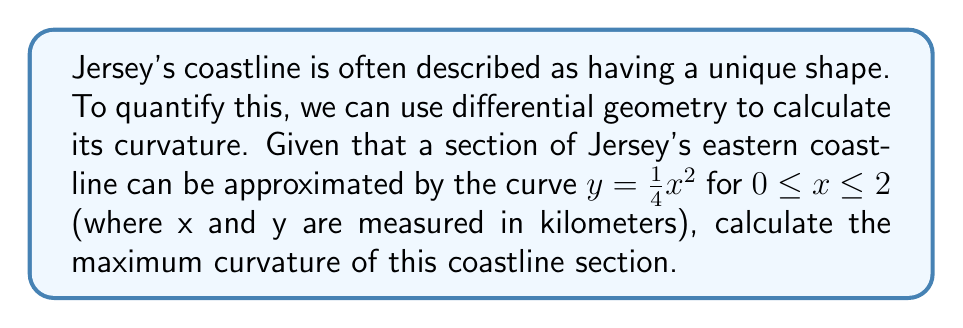Solve this math problem. To calculate the maximum curvature of the coastline section, we'll follow these steps:

1) The curvature $\kappa$ of a curve $y = f(x)$ is given by:

   $$\kappa = \frac{|f''(x)|}{(1 + [f'(x)]^2)^{3/2}}$$

2) For our curve $y = \frac{1}{4}x^2$, we need to find $f'(x)$ and $f''(x)$:

   $f'(x) = \frac{1}{2}x$
   $f''(x) = \frac{1}{2}$

3) Substituting these into the curvature formula:

   $$\kappa = \frac{|\frac{1}{2}|}{(1 + [\frac{1}{2}x]^2)^{3/2}}$$

4) Simplify:

   $$\kappa = \frac{0.5}{(1 + 0.25x^2)^{3/2}}$$

5) To find the maximum curvature, we need to find where this function is at its maximum. The denominator is smallest when $x = 0$, which will give us the maximum curvature.

6) When $x = 0$:

   $$\kappa_{max} = \frac{0.5}{(1 + 0)^{3/2}} = 0.5 \text{ km}^{-1}$$

Therefore, the maximum curvature of this section of Jersey's coastline is 0.5 km^(-1).
Answer: $0.5 \text{ km}^{-1}$ 